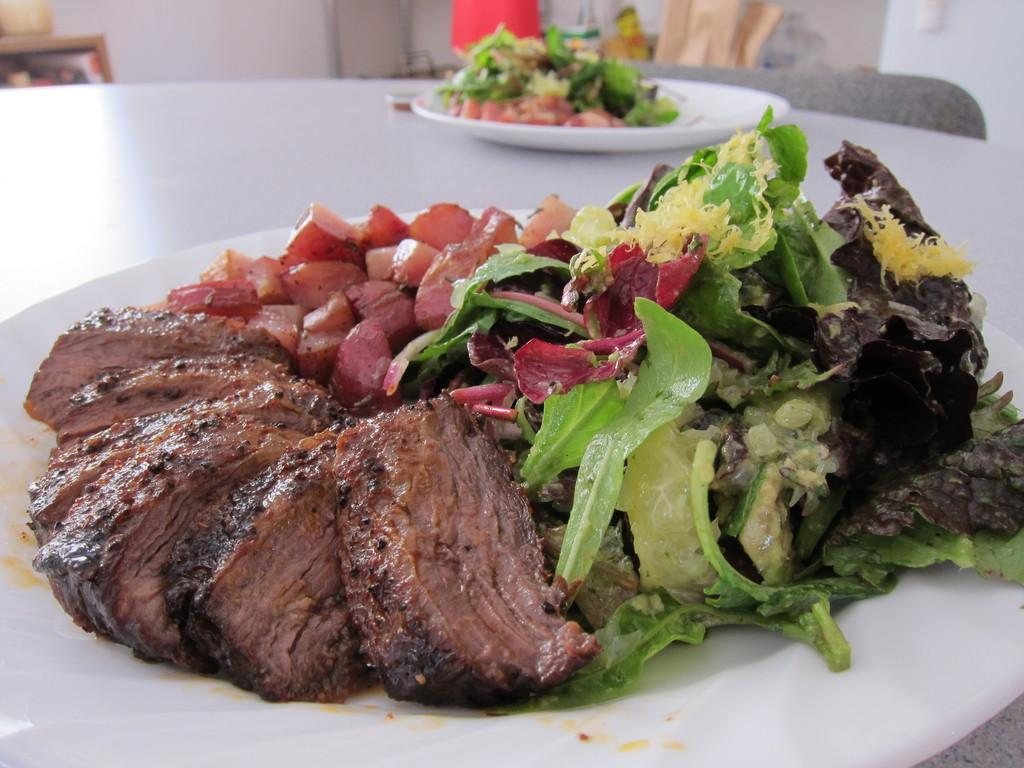What is the main piece of furniture in the image? There is a table in the image. What is on the table in the image? There are plates containing food on the table. What can be seen in the background of the image? There is a wall in the background of the image. How many turkeys are visible in the image? There are no turkeys present in the image. What is the cause of death for the person in the image? There is no person present in the image, and therefore no cause of death can be determined. 